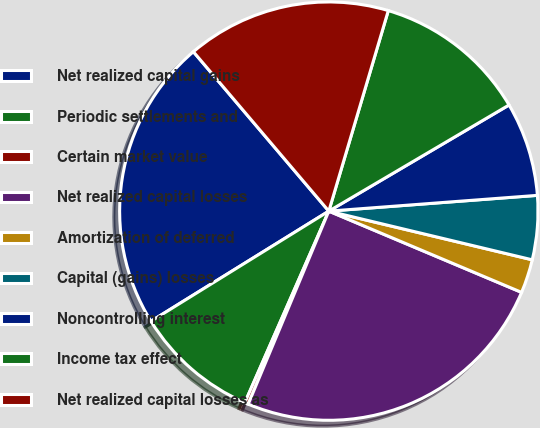Convert chart. <chart><loc_0><loc_0><loc_500><loc_500><pie_chart><fcel>Net realized capital gains<fcel>Periodic settlements and<fcel>Certain market value<fcel>Net realized capital losses<fcel>Amortization of deferred<fcel>Capital (gains) losses<fcel>Noncontrolling interest<fcel>Income tax effect<fcel>Net realized capital losses as<nl><fcel>22.62%<fcel>9.6%<fcel>0.28%<fcel>24.95%<fcel>2.61%<fcel>4.94%<fcel>7.27%<fcel>11.94%<fcel>15.8%<nl></chart> 